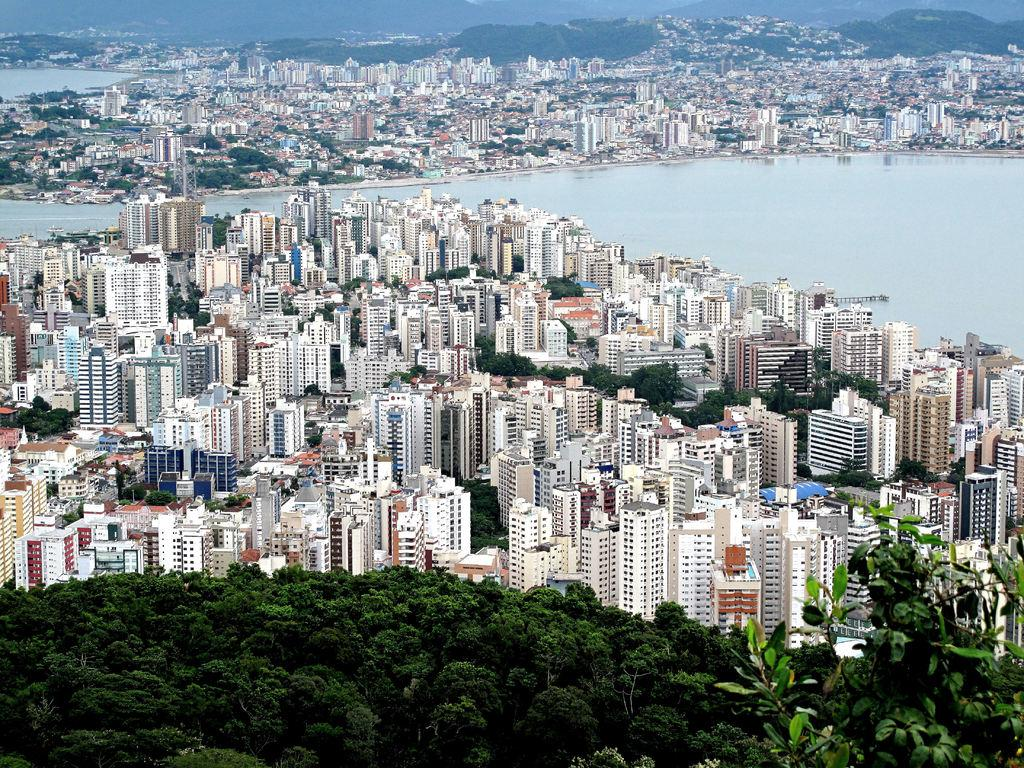What type of vegetation is present at the bottom of the image? There are trees at the bottom side of the image. What type of buildings can be seen in the image? There are skyscrapers in the image. Are there any other types of vegetation besides the ones at the bottom? Yes, there are trees in the image. What natural element is visible in the image? There is water visible in the image. Can you see any ducks swimming in the water in the image? There is no duck present in the image; only trees, skyscrapers, and water are visible. What type of frame is used for the image? The provided facts do not mention the frame of the image, so it cannot be determined from the information given. 